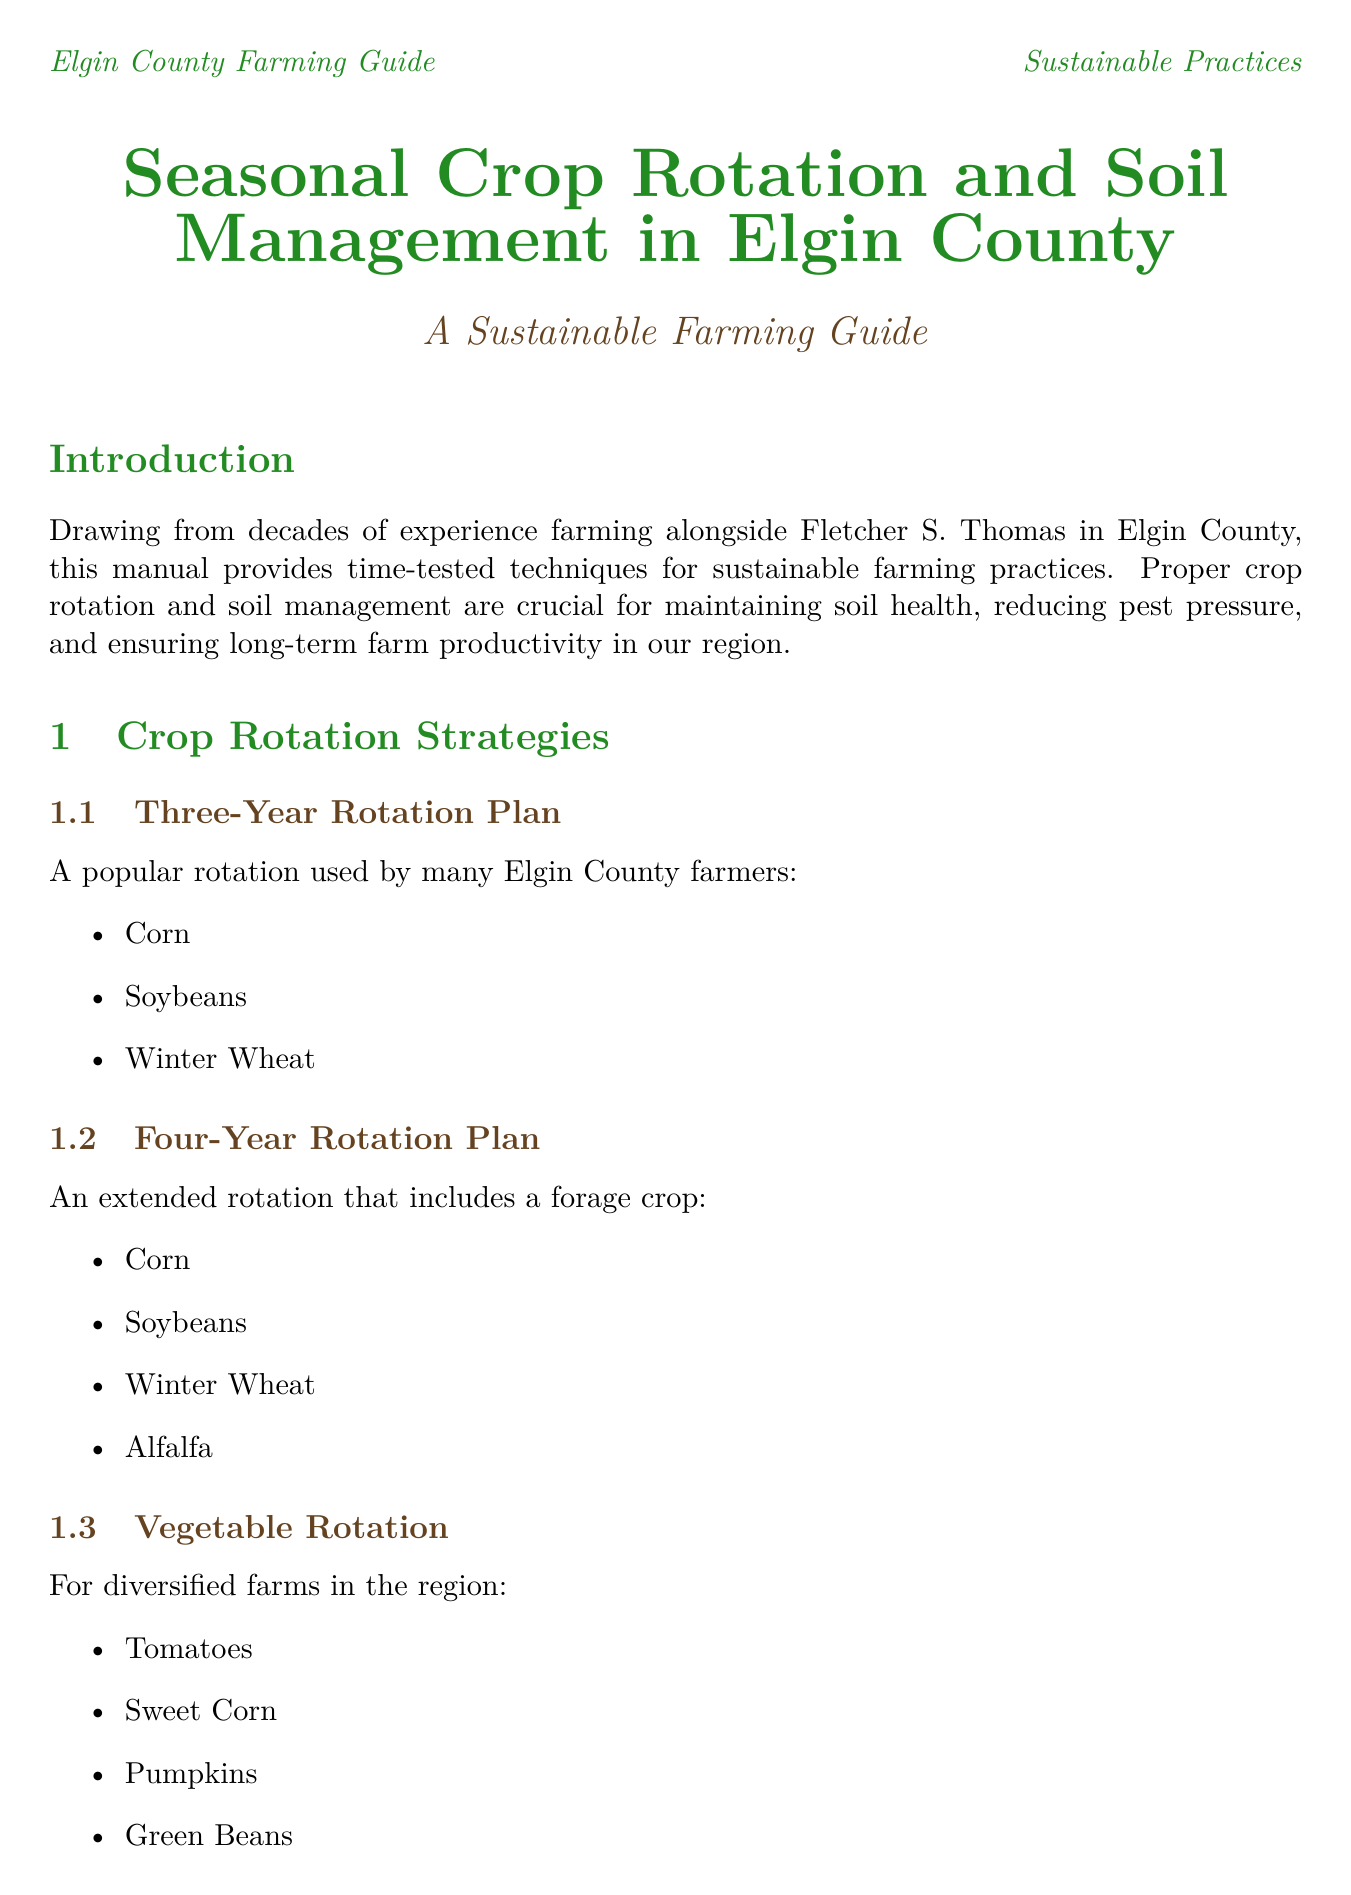What is the title of the manual? The title of the manual is stated in the document's header as the main subject of the guide.
Answer: Seasonal Crop Rotation and Soil Management in Elgin County: A Sustainable Farming Guide What crop follows soybeans in the Three-Year Rotation Plan? The crop sequence for the Three-Year Rotation Plan is specifically listed, identifying the crop that comes after soybeans.
Answer: Winter Wheat What organization provides education and support for sustainable farming practices? One of the local resources mentioned in the document focuses on education and support in sustainable farming methods.
Answer: Elgin Soil and Crop Improvement Association What is a key benefit of using cover crops? The document describes a specific advantage of planting cover crops in soil management techniques.
Answer: Prevent erosion and add organic matter Which farming practice is adopted by Kettle Creek Organics? The success story of Kettle Creek Organics highlights a specific farming practice they have implemented.
Answer: No-till practices During which season should soil testing and pH adjustment be done? The seasonal considerations section specifies tasks that should be performed in each season, including soil testing.
Answer: Spring What increase in corn yields did the Thomas Family Farm achieve? The case study for Thomas Family Farm provides a quantitative result regarding their corn yield improvement.
Answer: 15% What are the best practices for composting? The section on composting outlines the best practices for creating nutrient-rich soil amendments.
Answer: Use a mix of green and brown materials, turn compost regularly for proper aeration, apply finished compost in spring or fall 